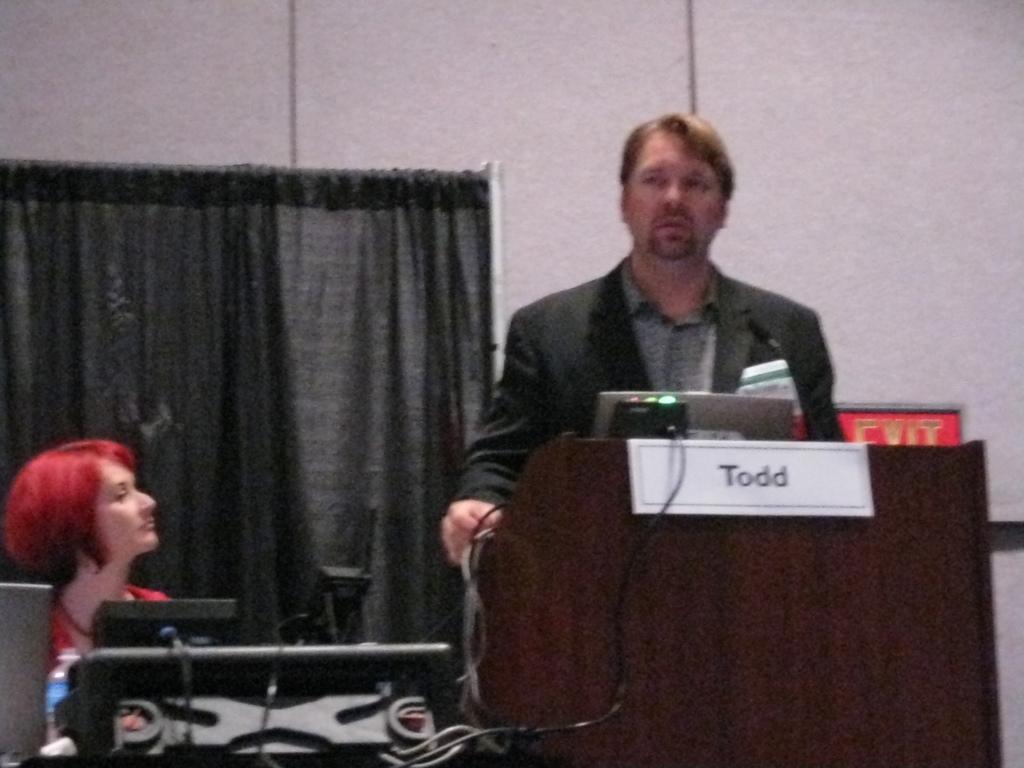Describe this image in one or two sentences. In-front of that person there is a podium with laptop. To that podium there is a whiteboard. Left side of the image we can see black curtain, woman and things. Background there is a white wall and signboard. 